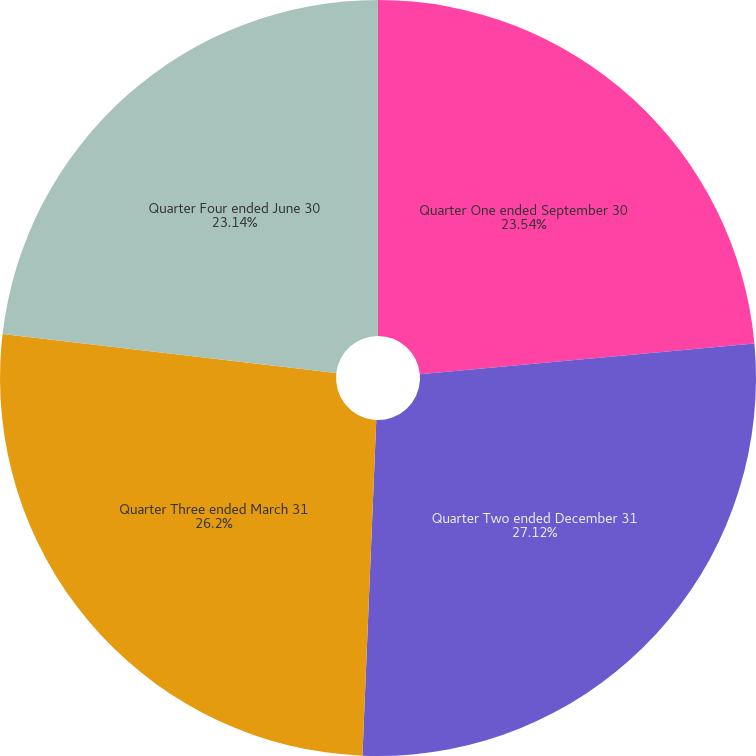<chart> <loc_0><loc_0><loc_500><loc_500><pie_chart><fcel>Quarter One ended September 30<fcel>Quarter Two ended December 31<fcel>Quarter Three ended March 31<fcel>Quarter Four ended June 30<nl><fcel>23.54%<fcel>27.11%<fcel>26.2%<fcel>23.14%<nl></chart> 